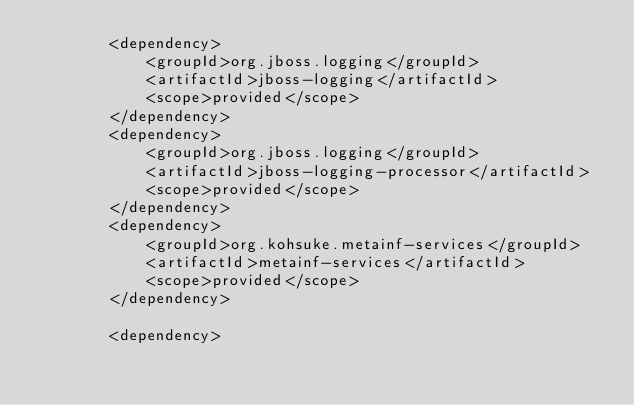<code> <loc_0><loc_0><loc_500><loc_500><_XML_>        <dependency>
            <groupId>org.jboss.logging</groupId>
            <artifactId>jboss-logging</artifactId>
            <scope>provided</scope>
        </dependency>
        <dependency>
            <groupId>org.jboss.logging</groupId>
            <artifactId>jboss-logging-processor</artifactId>
            <scope>provided</scope>
        </dependency>
        <dependency>
            <groupId>org.kohsuke.metainf-services</groupId>
            <artifactId>metainf-services</artifactId>
            <scope>provided</scope>
        </dependency>

        <dependency></code> 